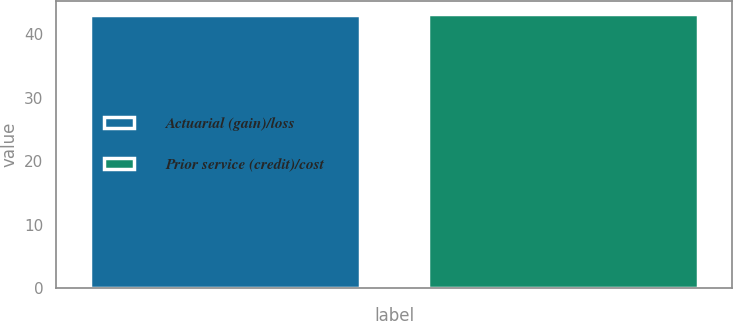<chart> <loc_0><loc_0><loc_500><loc_500><bar_chart><fcel>Actuarial (gain)/loss<fcel>Prior service (credit)/cost<nl><fcel>43<fcel>43.1<nl></chart> 